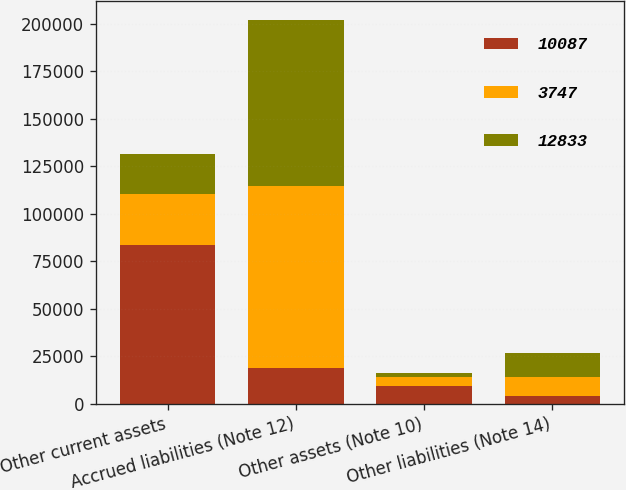Convert chart. <chart><loc_0><loc_0><loc_500><loc_500><stacked_bar_chart><ecel><fcel>Other current assets<fcel>Accrued liabilities (Note 12)<fcel>Other assets (Note 10)<fcel>Other liabilities (Note 14)<nl><fcel>10087<fcel>83582<fcel>18590<fcel>9189<fcel>3747<nl><fcel>3747<fcel>26741<fcel>96087<fcel>4659<fcel>10087<nl><fcel>12833<fcel>20771<fcel>87205<fcel>2199<fcel>12833<nl></chart> 